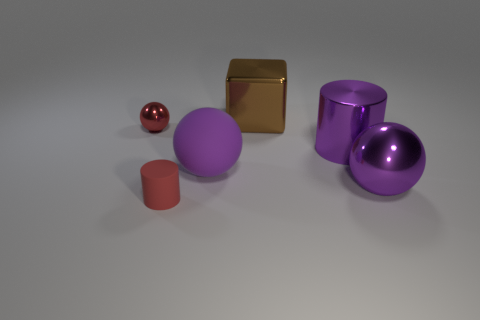How many objects are there and can you describe their shapes? There are five objects in total: a small red sphere, a matte purple ball, a purple cylinder and a cube both with metallic sheen, and a smaller matte cylinder, each exhibiting distinct geometric shapes. 